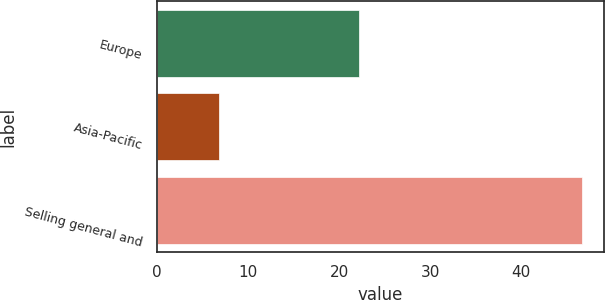Convert chart. <chart><loc_0><loc_0><loc_500><loc_500><bar_chart><fcel>Europe<fcel>Asia-Pacific<fcel>Selling general and<nl><fcel>22.2<fcel>6.8<fcel>46.7<nl></chart> 